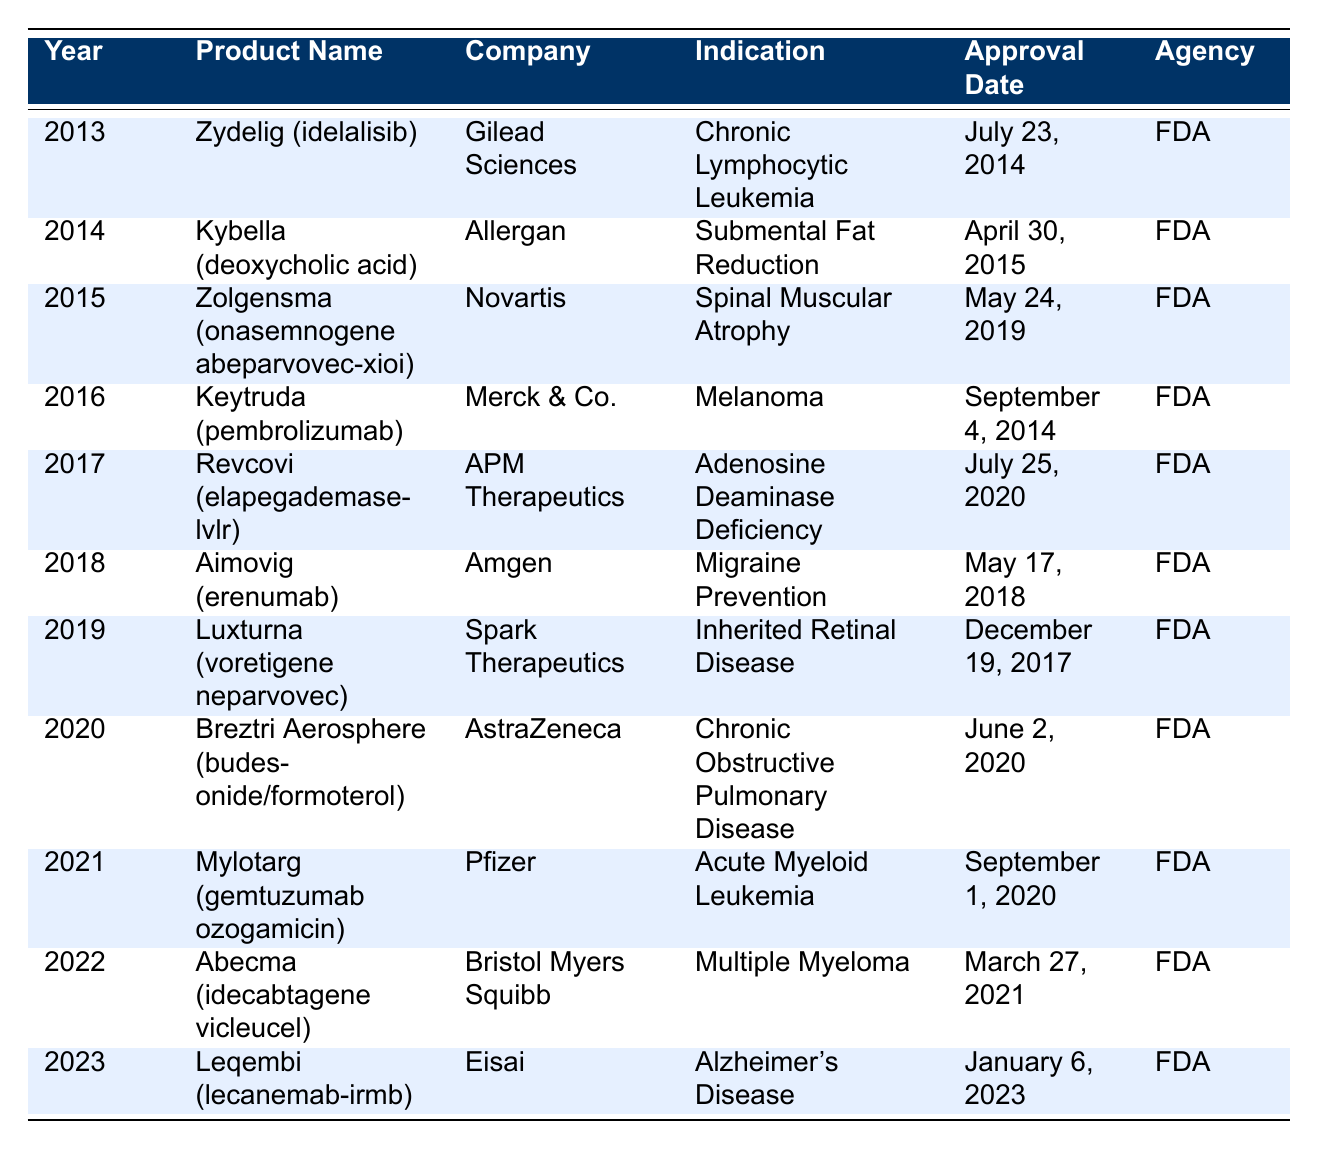What is the name of the product approved in 2021? By locating the row for the year 2021 in the table, we find that the product listed is Mylotarg (gemtuzumab ozogamicin).
Answer: Mylotarg (gemtuzumab ozogamicin) Which company developed Zydelig? Referring to the entry for the product Zydelig in the table, we can clearly see that it was developed by Gilead Sciences.
Answer: Gilead Sciences How many products were approved after 2018? To determine the number of products approved after 2018, we count the rows for the years 2019, 2020, 2021, 2022, and 2023, which gives us a total of 5 products.
Answer: 5 Was Aimovig approved before or after Zolgensma? Checking the approval dates for Aimovig (approved on May 17, 2018) and Zolgensma (approved on May 24, 2019), we see that Aimovig was approved before Zolgensma.
Answer: Before What is the average approval year of all the products listed? To compute the average, we sum the years from 2013 to 2023, which is 2013 + 2014 + 2015 + 2016 + 2017 + 2018 + 2019 + 2020 + 2021 + 2022 + 2023 = 2217. With 11 products, the average year is 2217/11 = 201.545, rounded to 2018.
Answer: 2018 How many of the products were indicated for cancer treatment? From the table, we identify the products: Zydelig (Chronic Lymphocytic Leukemia), Keytruda (Melanoma), Zolgensma (Spinal Muscular Atrophy, not cancer), Revcovi (Adenosine Deaminase Deficiency, not cancer), and Abecma (Multiple Myeloma), which totals 3 products indicated for cancer.
Answer: 3 Is there any product indicated for Alzheimer's Disease? Looking through the table, we find that Leqembi (lecanemab-irmb) is indicated for Alzheimer's Disease, confirming that there is indeed a product for this indication.
Answer: Yes Which product had the earliest approval date among the listed approvals? By analyzing the approval dates, we see that Keytruda (approved on September 4, 2014) has the earliest date compared to others, as no product before that year is mentioned.
Answer: Keytruda (pembrolizumab) 